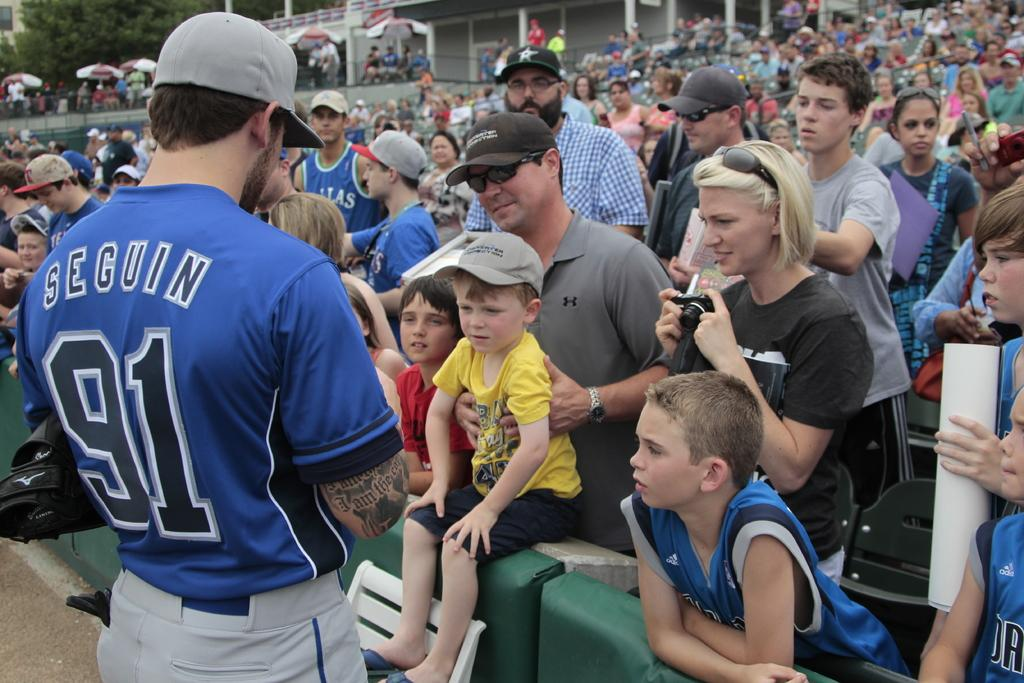Provide a one-sentence caption for the provided image. A family talks with a man wearing a jersey that has the name SEGUIN and the number 91 on it. 